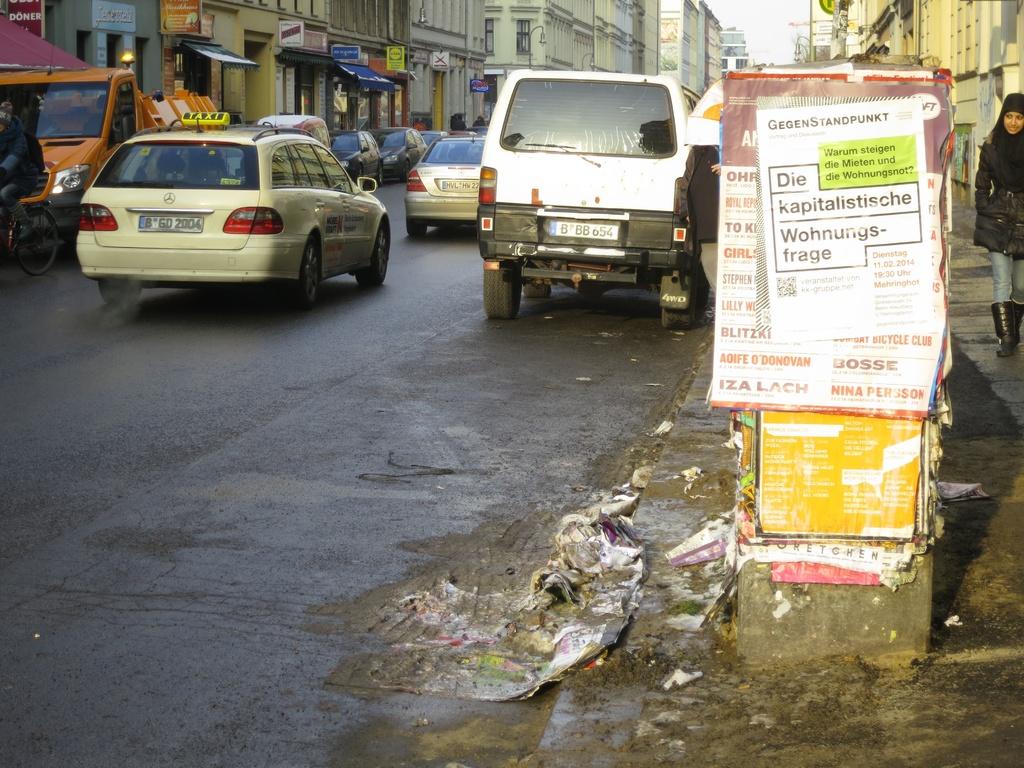Is die a belgium word?
Provide a short and direct response. Yes. 